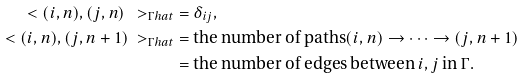Convert formula to latex. <formula><loc_0><loc_0><loc_500><loc_500>\ < ( i , n ) , ( j , n ) \ > _ { \Gamma h a t } & = \delta _ { i j } , \\ \ < ( i , n ) , ( j , n + 1 ) \ > _ { \Gamma h a t } & = \text {the number of paths} ( i , n ) \to \cdots \to ( j , n + 1 ) \\ & = \text {the number of edges between } i , j \text { in } \Gamma .</formula> 